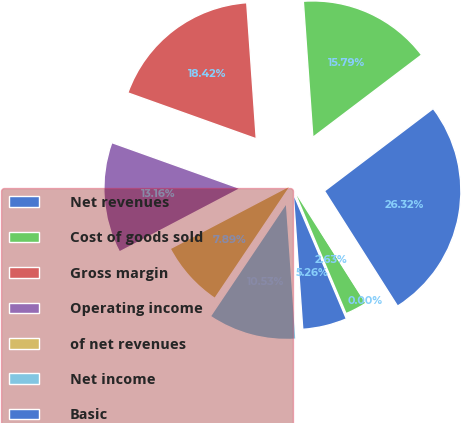<chart> <loc_0><loc_0><loc_500><loc_500><pie_chart><fcel>Net revenues<fcel>Cost of goods sold<fcel>Gross margin<fcel>Operating income<fcel>of net revenues<fcel>Net income<fcel>Basic<fcel>Diluted<fcel>Dividends declared per share<nl><fcel>26.32%<fcel>15.79%<fcel>18.42%<fcel>13.16%<fcel>7.89%<fcel>10.53%<fcel>5.26%<fcel>2.63%<fcel>0.0%<nl></chart> 